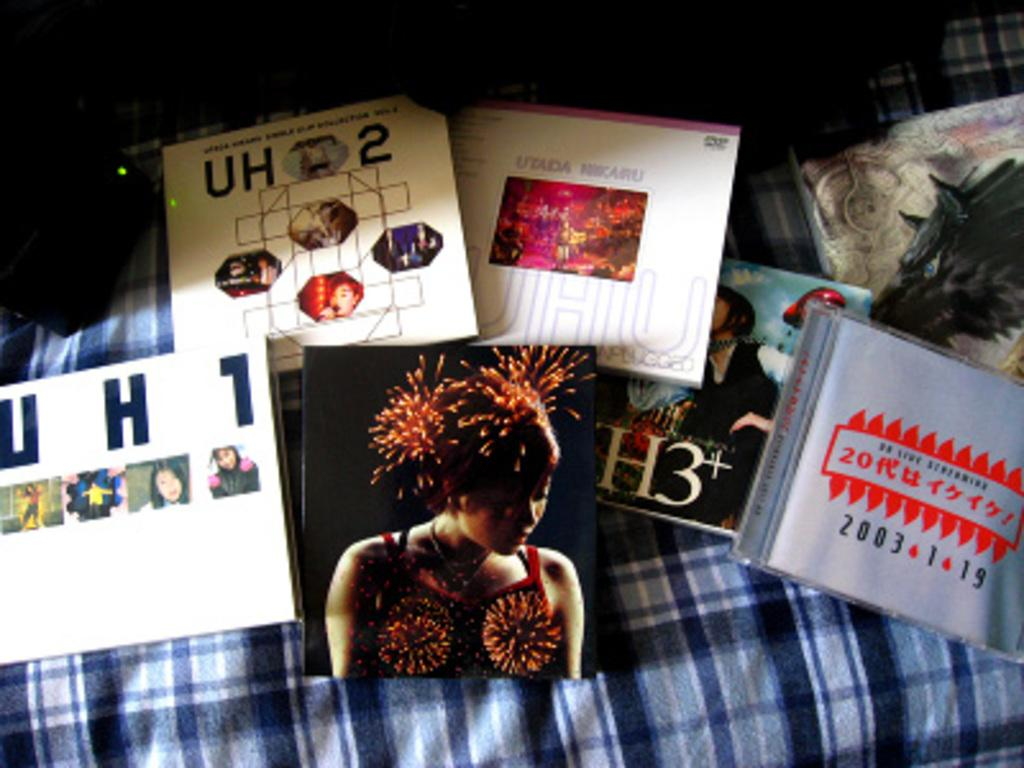What type of items are present in the image? There are books in the image. What can be found on the surface of the books? The books have text and images on their surface. What is the color of the books' surface? The surface of the books is blue in color. What can be seen on the left side of the image? There is an object on the left side of the image. What is the color of the object on the left side? The object is black in color. How does the eye react to the bell in the aftermath of the image? There is no eye or bell present in the image, and therefore no such reaction can be observed. 